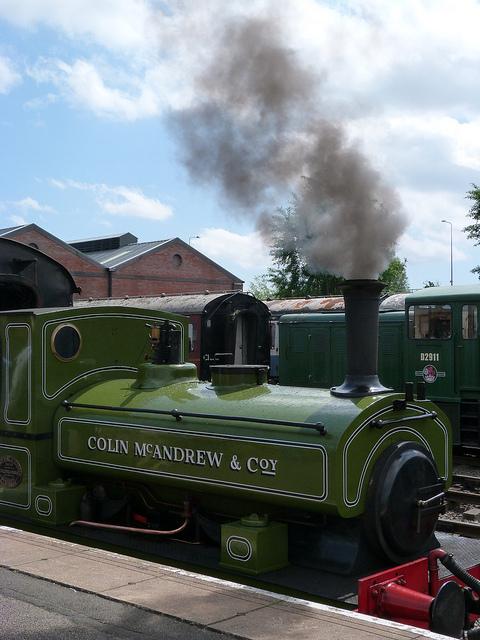What powers this engine?
Write a very short answer. Coal. What color is the train?
Write a very short answer. Green. What is the name of the engine?
Write a very short answer. Colin mcandrew & coy. 